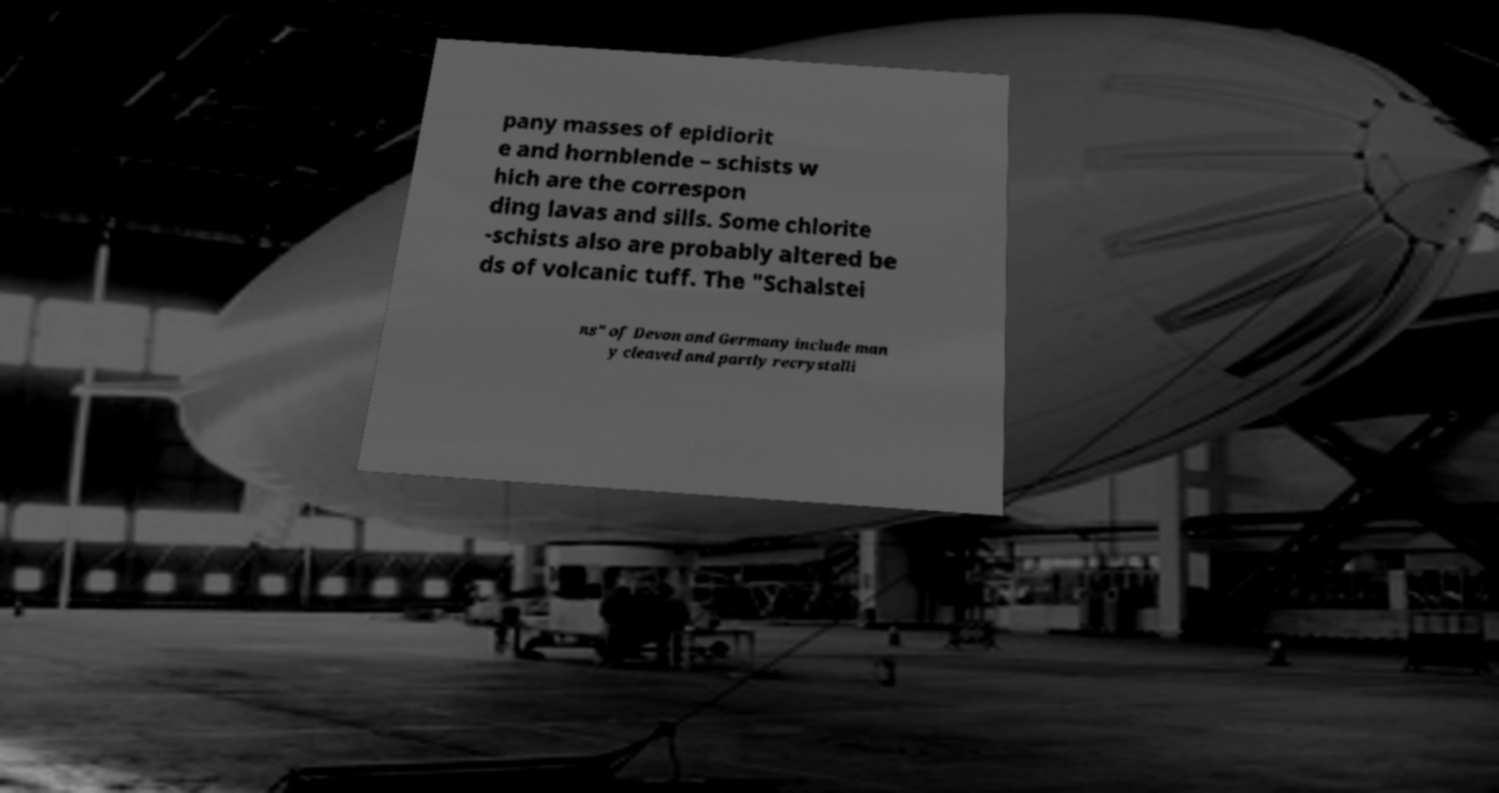Could you assist in decoding the text presented in this image and type it out clearly? pany masses of epidiorit e and hornblende – schists w hich are the correspon ding lavas and sills. Some chlorite -schists also are probably altered be ds of volcanic tuff. The "Schalstei ns" of Devon and Germany include man y cleaved and partly recrystalli 